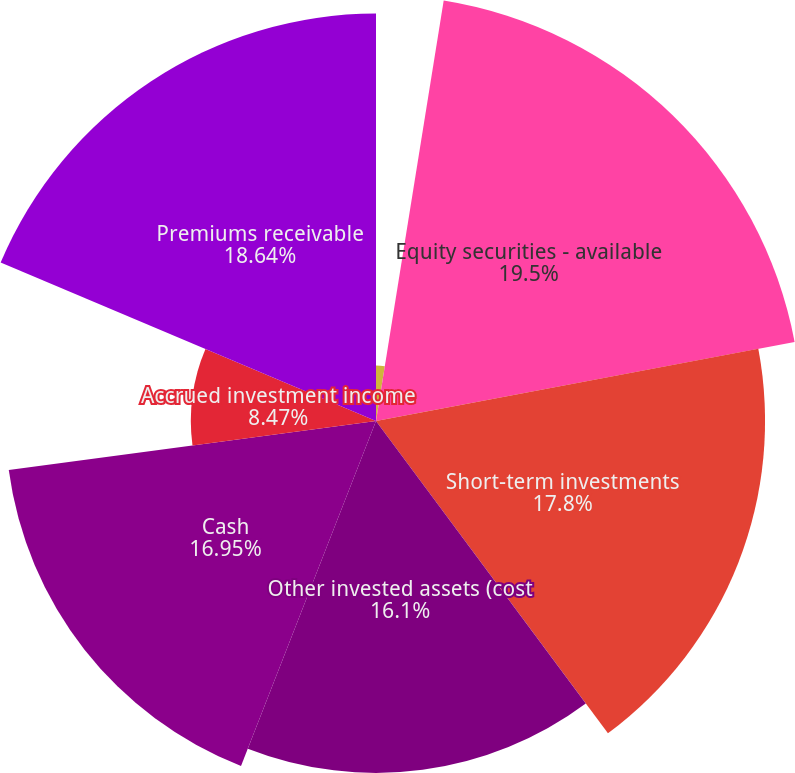Convert chart. <chart><loc_0><loc_0><loc_500><loc_500><pie_chart><fcel>(Dollars and share amounts in<fcel>Fixed maturities - available<fcel>Equity securities - available<fcel>Short-term investments<fcel>Other invested assets (cost<fcel>Cash<fcel>Accrued investment income<fcel>Premiums receivable<nl><fcel>0.0%<fcel>2.54%<fcel>19.49%<fcel>17.8%<fcel>16.1%<fcel>16.95%<fcel>8.47%<fcel>18.64%<nl></chart> 